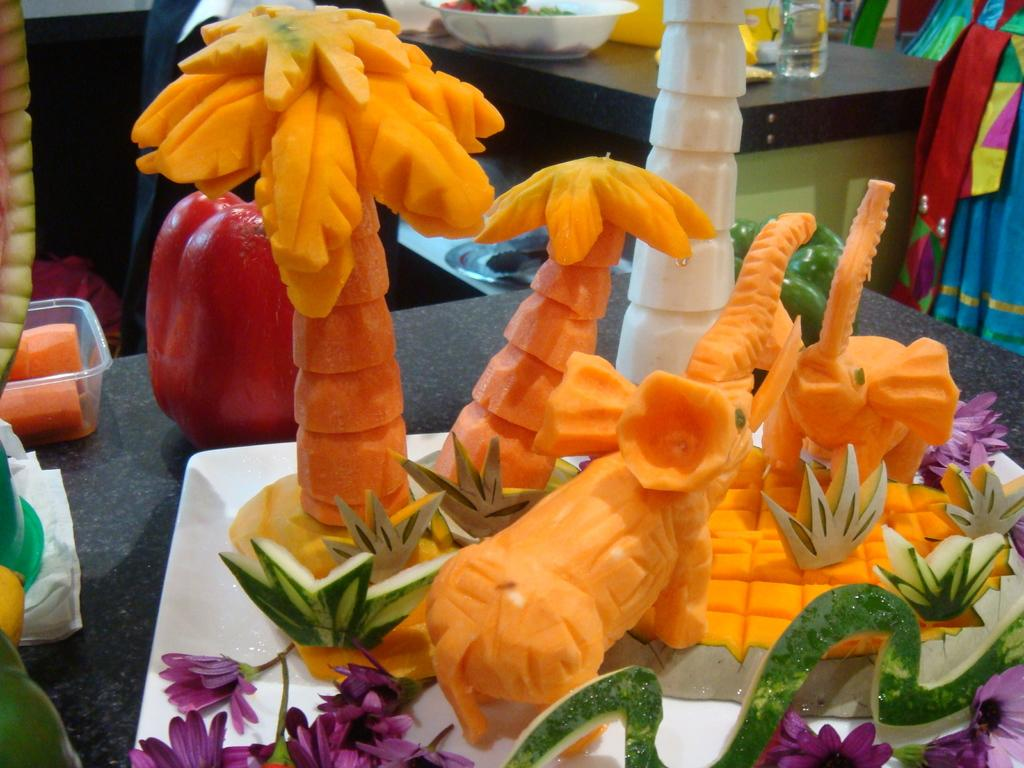What is on the plate in the image? There is orange fruit art on the plate. What color is the plate in the image? The plate is white. What other objects or elements can be seen in the image? There are purple flowers and fruits visible in the background of the image. What type of insurance is being discussed in the image? There is no discussion of insurance in the image; it features a white plate with orange fruit art, purple flowers, and fruits in the background. 